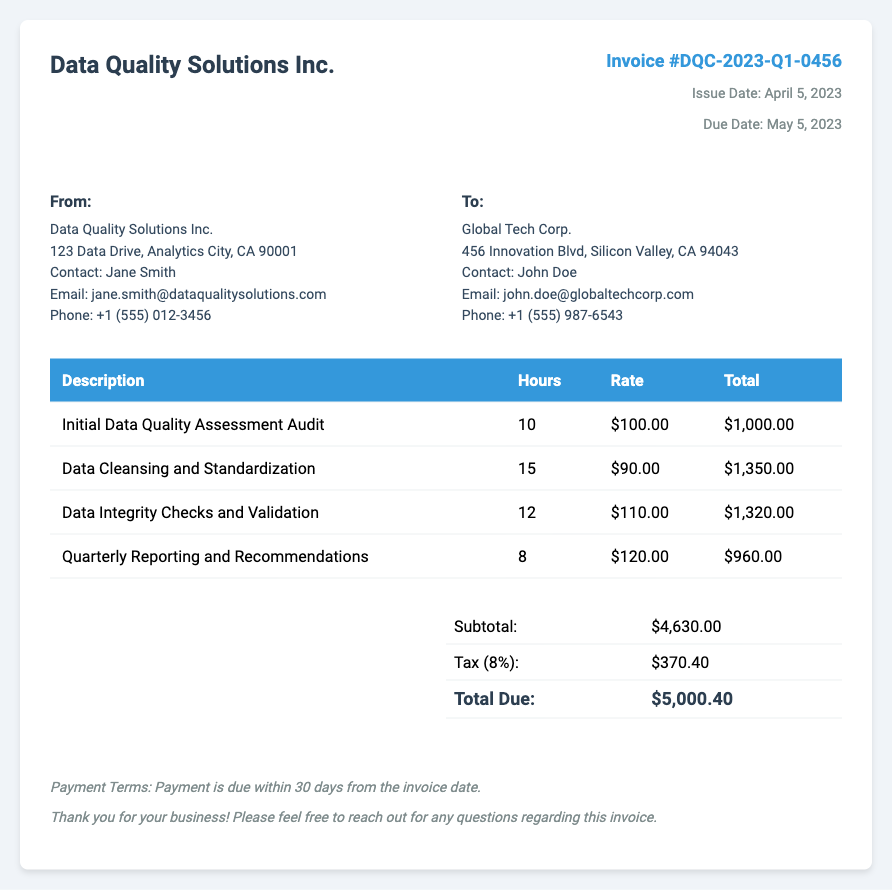What is the invoice number? The invoice number can be found in the invoice details section and is labeled clearly.
Answer: DQC-2023-Q1-0456 Who is the contact person for Data Quality Solutions Inc.? This information is available in the "From" section of the invoice where the company details are provided.
Answer: Jane Smith What is the due date for the invoice? The due date is mentioned in the invoice details and indicates when the payment is expected.
Answer: May 5, 2023 How many hours were billed for Data Cleansing and Standardization? This detail can be found in the itemized charges table, under the relevant service description.
Answer: 15 What is the subtotal amount before tax? The subtotal is the total amount of services rendered before any additional charges such as tax, shown in the summary section.
Answer: $4,630.00 What is the tax rate applied to the invoice? The invoice specifies the tax calculation applied, which can be found in the summary table.
Answer: 8% How much is the total due? The total due is clearly indicated in the summary section at the end of the invoice.
Answer: $5,000.40 What service was performed for the least number of hours? By analyzing the itemized charges, the service with the least hours indicates the smallest entry in the hours column.
Answer: Quarterly Reporting and Recommendations What is the payment term for the invoice? Payment terms are usually included in the notes section at the bottom of the invoice.
Answer: Payment is due within 30 days from the invoice date 